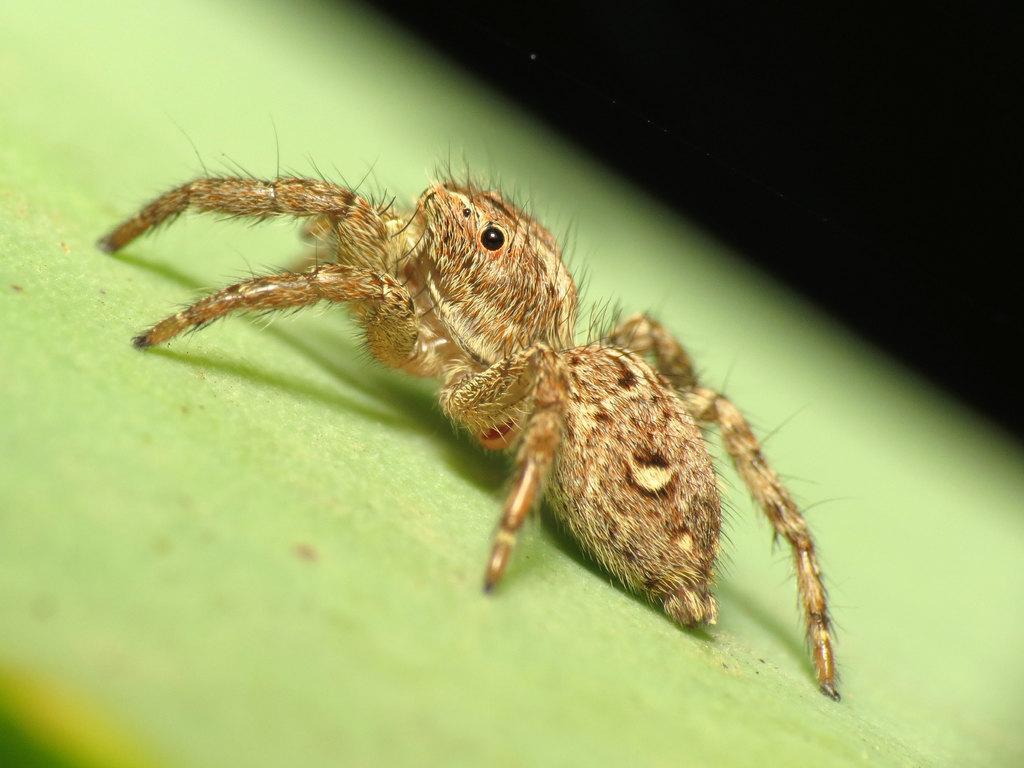Describe this image in one or two sentences. On this green surface there is an insect. Background it is dark. 